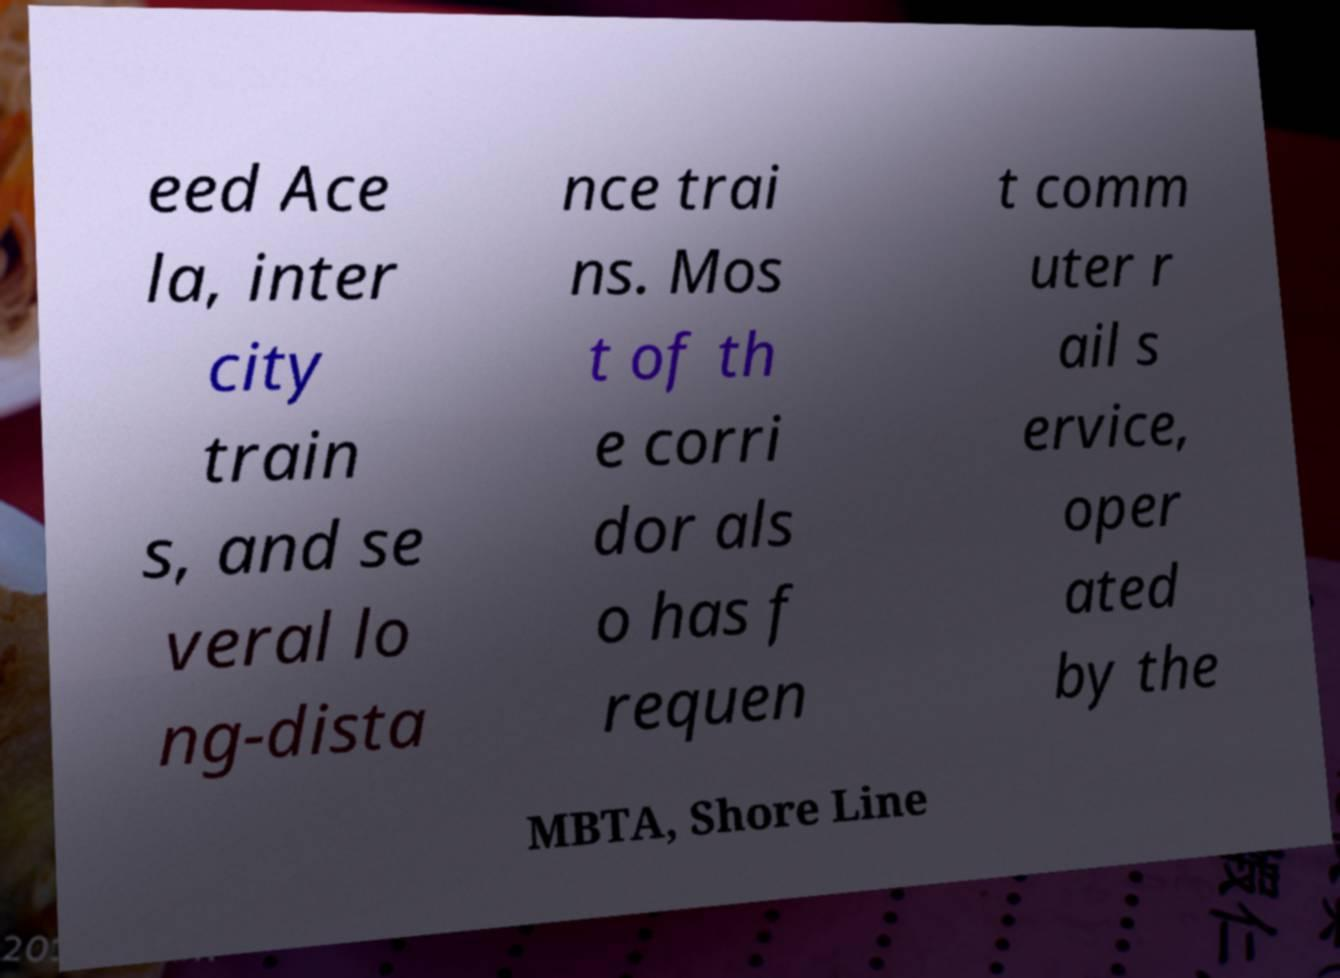Could you extract and type out the text from this image? eed Ace la, inter city train s, and se veral lo ng-dista nce trai ns. Mos t of th e corri dor als o has f requen t comm uter r ail s ervice, oper ated by the MBTA, Shore Line 